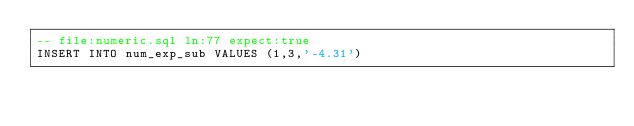Convert code to text. <code><loc_0><loc_0><loc_500><loc_500><_SQL_>-- file:numeric.sql ln:77 expect:true
INSERT INTO num_exp_sub VALUES (1,3,'-4.31')
</code> 